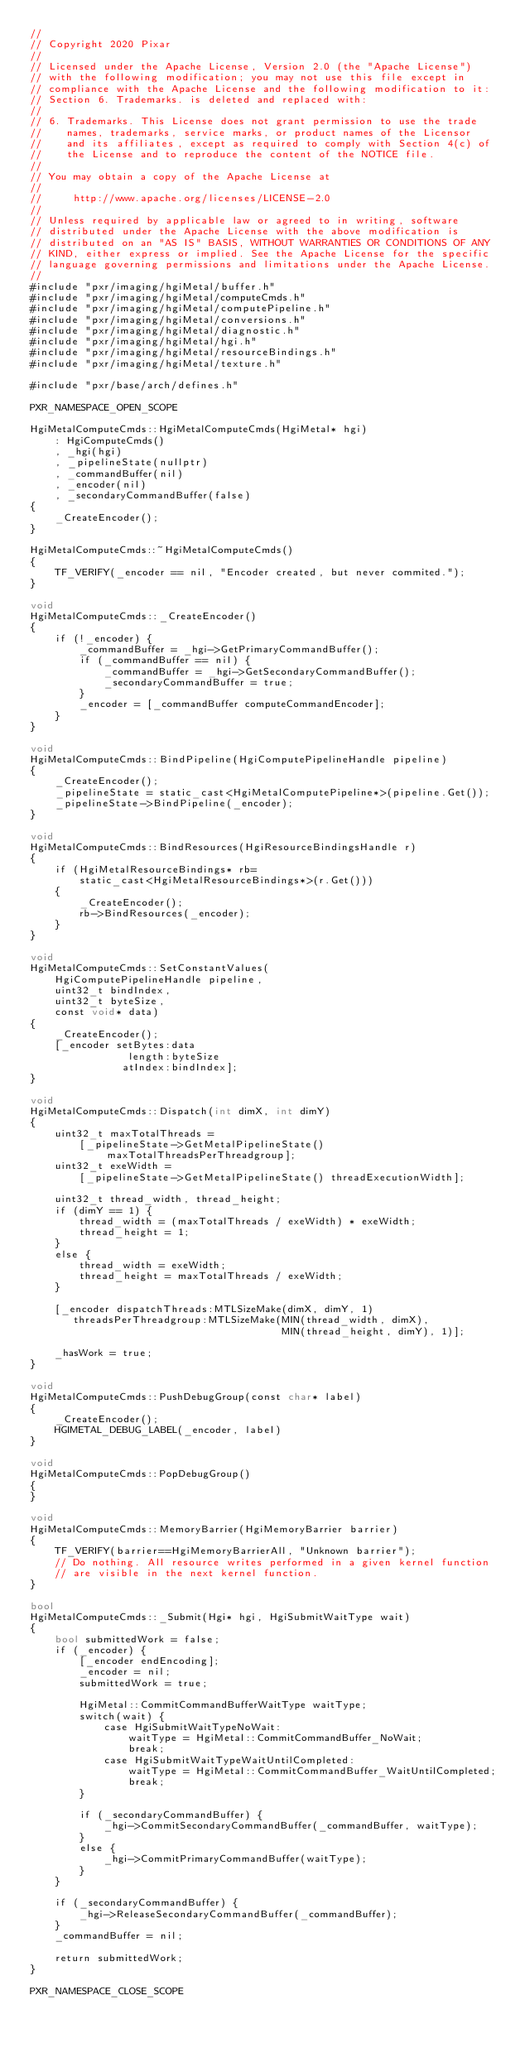Convert code to text. <code><loc_0><loc_0><loc_500><loc_500><_ObjectiveC_>//
// Copyright 2020 Pixar
//
// Licensed under the Apache License, Version 2.0 (the "Apache License")
// with the following modification; you may not use this file except in
// compliance with the Apache License and the following modification to it:
// Section 6. Trademarks. is deleted and replaced with:
//
// 6. Trademarks. This License does not grant permission to use the trade
//    names, trademarks, service marks, or product names of the Licensor
//    and its affiliates, except as required to comply with Section 4(c) of
//    the License and to reproduce the content of the NOTICE file.
//
// You may obtain a copy of the Apache License at
//
//     http://www.apache.org/licenses/LICENSE-2.0
//
// Unless required by applicable law or agreed to in writing, software
// distributed under the Apache License with the above modification is
// distributed on an "AS IS" BASIS, WITHOUT WARRANTIES OR CONDITIONS OF ANY
// KIND, either express or implied. See the Apache License for the specific
// language governing permissions and limitations under the Apache License.
//
#include "pxr/imaging/hgiMetal/buffer.h"
#include "pxr/imaging/hgiMetal/computeCmds.h"
#include "pxr/imaging/hgiMetal/computePipeline.h"
#include "pxr/imaging/hgiMetal/conversions.h"
#include "pxr/imaging/hgiMetal/diagnostic.h"
#include "pxr/imaging/hgiMetal/hgi.h"
#include "pxr/imaging/hgiMetal/resourceBindings.h"
#include "pxr/imaging/hgiMetal/texture.h"

#include "pxr/base/arch/defines.h"

PXR_NAMESPACE_OPEN_SCOPE

HgiMetalComputeCmds::HgiMetalComputeCmds(HgiMetal* hgi)
    : HgiComputeCmds()
    , _hgi(hgi)
    , _pipelineState(nullptr)
    , _commandBuffer(nil)
    , _encoder(nil)
    , _secondaryCommandBuffer(false)
{
    _CreateEncoder();
}

HgiMetalComputeCmds::~HgiMetalComputeCmds()
{
    TF_VERIFY(_encoder == nil, "Encoder created, but never commited.");
}

void
HgiMetalComputeCmds::_CreateEncoder()
{
    if (!_encoder) {
        _commandBuffer = _hgi->GetPrimaryCommandBuffer();
        if (_commandBuffer == nil) {
            _commandBuffer = _hgi->GetSecondaryCommandBuffer();
            _secondaryCommandBuffer = true;
        }
        _encoder = [_commandBuffer computeCommandEncoder];
    }
}

void
HgiMetalComputeCmds::BindPipeline(HgiComputePipelineHandle pipeline)
{
    _CreateEncoder();
    _pipelineState = static_cast<HgiMetalComputePipeline*>(pipeline.Get());
    _pipelineState->BindPipeline(_encoder);
}

void
HgiMetalComputeCmds::BindResources(HgiResourceBindingsHandle r)
{
    if (HgiMetalResourceBindings* rb=
        static_cast<HgiMetalResourceBindings*>(r.Get()))
    {
        _CreateEncoder();
        rb->BindResources(_encoder);
    }
}

void
HgiMetalComputeCmds::SetConstantValues(
    HgiComputePipelineHandle pipeline,
    uint32_t bindIndex,
    uint32_t byteSize,
    const void* data)
{
    _CreateEncoder();
    [_encoder setBytes:data
                length:byteSize
               atIndex:bindIndex];
}

void
HgiMetalComputeCmds::Dispatch(int dimX, int dimY)
{
    uint32_t maxTotalThreads =
        [_pipelineState->GetMetalPipelineState() maxTotalThreadsPerThreadgroup];
    uint32_t exeWidth =
        [_pipelineState->GetMetalPipelineState() threadExecutionWidth];

    uint32_t thread_width, thread_height;
    if (dimY == 1) {
        thread_width = (maxTotalThreads / exeWidth) * exeWidth;
        thread_height = 1;
    }
    else {
        thread_width = exeWidth;
        thread_height = maxTotalThreads / exeWidth;
    }

    [_encoder dispatchThreads:MTLSizeMake(dimX, dimY, 1)
       threadsPerThreadgroup:MTLSizeMake(MIN(thread_width, dimX),
                                         MIN(thread_height, dimY), 1)];

    _hasWork = true;
}

void
HgiMetalComputeCmds::PushDebugGroup(const char* label)
{
    _CreateEncoder();
    HGIMETAL_DEBUG_LABEL(_encoder, label)
}

void
HgiMetalComputeCmds::PopDebugGroup()
{
}

void
HgiMetalComputeCmds::MemoryBarrier(HgiMemoryBarrier barrier)
{
    TF_VERIFY(barrier==HgiMemoryBarrierAll, "Unknown barrier");
    // Do nothing. All resource writes performed in a given kernel function
    // are visible in the next kernel function.
}

bool
HgiMetalComputeCmds::_Submit(Hgi* hgi, HgiSubmitWaitType wait)
{
    bool submittedWork = false;
    if (_encoder) {
        [_encoder endEncoding];
        _encoder = nil;
        submittedWork = true;

        HgiMetal::CommitCommandBufferWaitType waitType;
        switch(wait) {
            case HgiSubmitWaitTypeNoWait:
                waitType = HgiMetal::CommitCommandBuffer_NoWait;
                break;
            case HgiSubmitWaitTypeWaitUntilCompleted:
                waitType = HgiMetal::CommitCommandBuffer_WaitUntilCompleted;
                break;
        }

        if (_secondaryCommandBuffer) {
            _hgi->CommitSecondaryCommandBuffer(_commandBuffer, waitType);
        }
        else {
            _hgi->CommitPrimaryCommandBuffer(waitType);
        }
    }
    
    if (_secondaryCommandBuffer) {
        _hgi->ReleaseSecondaryCommandBuffer(_commandBuffer);
    }
    _commandBuffer = nil;

    return submittedWork;
}

PXR_NAMESPACE_CLOSE_SCOPE
</code> 